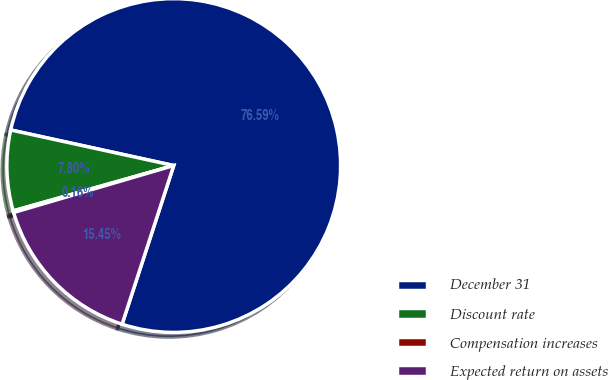Convert chart. <chart><loc_0><loc_0><loc_500><loc_500><pie_chart><fcel>December 31<fcel>Discount rate<fcel>Compensation increases<fcel>Expected return on assets<nl><fcel>76.59%<fcel>7.8%<fcel>0.16%<fcel>15.45%<nl></chart> 